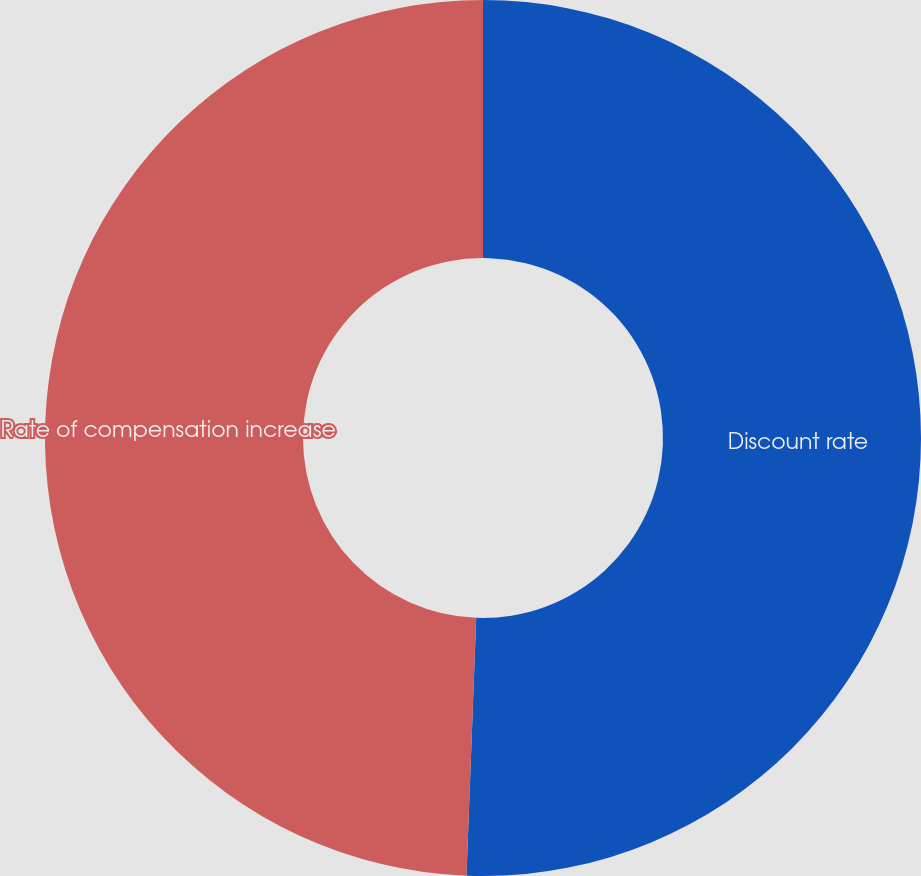Convert chart. <chart><loc_0><loc_0><loc_500><loc_500><pie_chart><fcel>Discount rate<fcel>Rate of compensation increase<nl><fcel>50.6%<fcel>49.4%<nl></chart> 